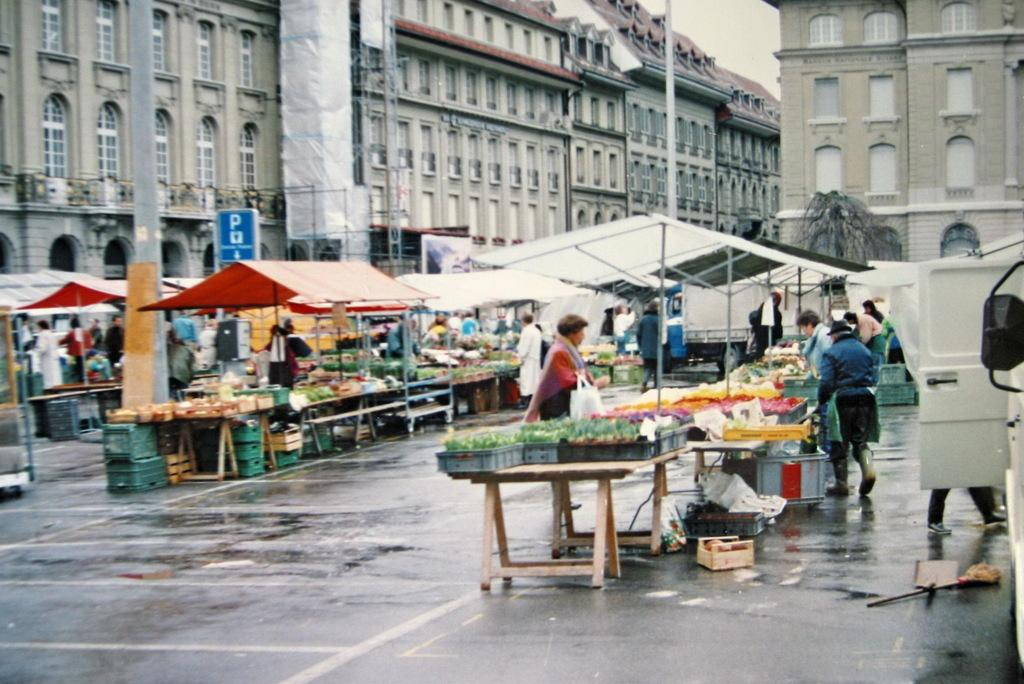What is the woman doing in the image? The woman is standing on the road. What is in front of the woman? There is a table in front of the woman. What is on the table? There are vegetables on the table. What else can be seen in the image? There are stalls and a building visible in the image. Are there any natural elements present in the image? Yes, there is a tree in the image. What type of mint is growing under the tree in the image? There is no mint growing under the tree in the image; it only features a tree and no plants are mentioned. Is there a dog accompanying the woman in the image? No, there is no dog present in the image. 